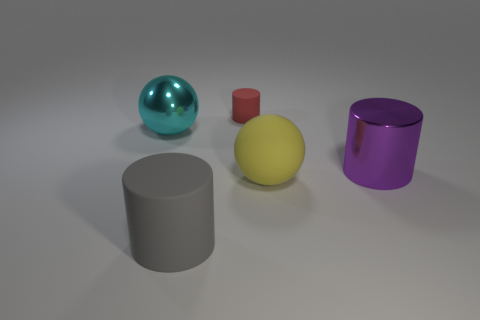What number of other objects are there of the same shape as the cyan shiny object?
Keep it short and to the point. 1. What number of objects are gray matte cylinders or metallic balls that are in front of the red rubber cylinder?
Make the answer very short. 2. Are there more objects behind the small red rubber cylinder than yellow objects right of the big purple metal cylinder?
Make the answer very short. No. The big rubber thing that is to the left of the cylinder that is behind the metallic thing to the left of the large purple cylinder is what shape?
Offer a very short reply. Cylinder. There is a shiny object that is on the right side of the large sphere that is in front of the large purple shiny object; what is its shape?
Your response must be concise. Cylinder. Are there any large gray cylinders that have the same material as the purple cylinder?
Provide a succinct answer. No. How many yellow things are either metal cylinders or large matte objects?
Offer a terse response. 1. Are there any tiny cylinders of the same color as the small thing?
Ensure brevity in your answer.  No. The gray cylinder that is made of the same material as the red cylinder is what size?
Keep it short and to the point. Large. What number of cylinders are either tiny blue metallic objects or big matte objects?
Keep it short and to the point. 1. 